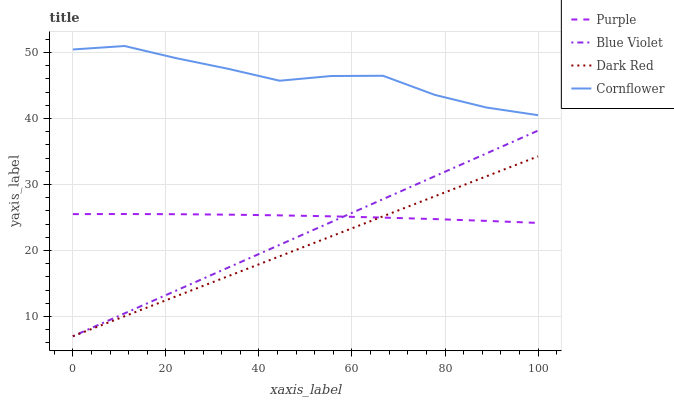Does Dark Red have the minimum area under the curve?
Answer yes or no. Yes. Does Cornflower have the maximum area under the curve?
Answer yes or no. Yes. Does Blue Violet have the minimum area under the curve?
Answer yes or no. No. Does Blue Violet have the maximum area under the curve?
Answer yes or no. No. Is Blue Violet the smoothest?
Answer yes or no. Yes. Is Cornflower the roughest?
Answer yes or no. Yes. Is Dark Red the smoothest?
Answer yes or no. No. Is Dark Red the roughest?
Answer yes or no. No. Does Cornflower have the lowest value?
Answer yes or no. No. Does Cornflower have the highest value?
Answer yes or no. Yes. Does Dark Red have the highest value?
Answer yes or no. No. Is Blue Violet less than Cornflower?
Answer yes or no. Yes. Is Cornflower greater than Dark Red?
Answer yes or no. Yes. Does Blue Violet intersect Cornflower?
Answer yes or no. No. 